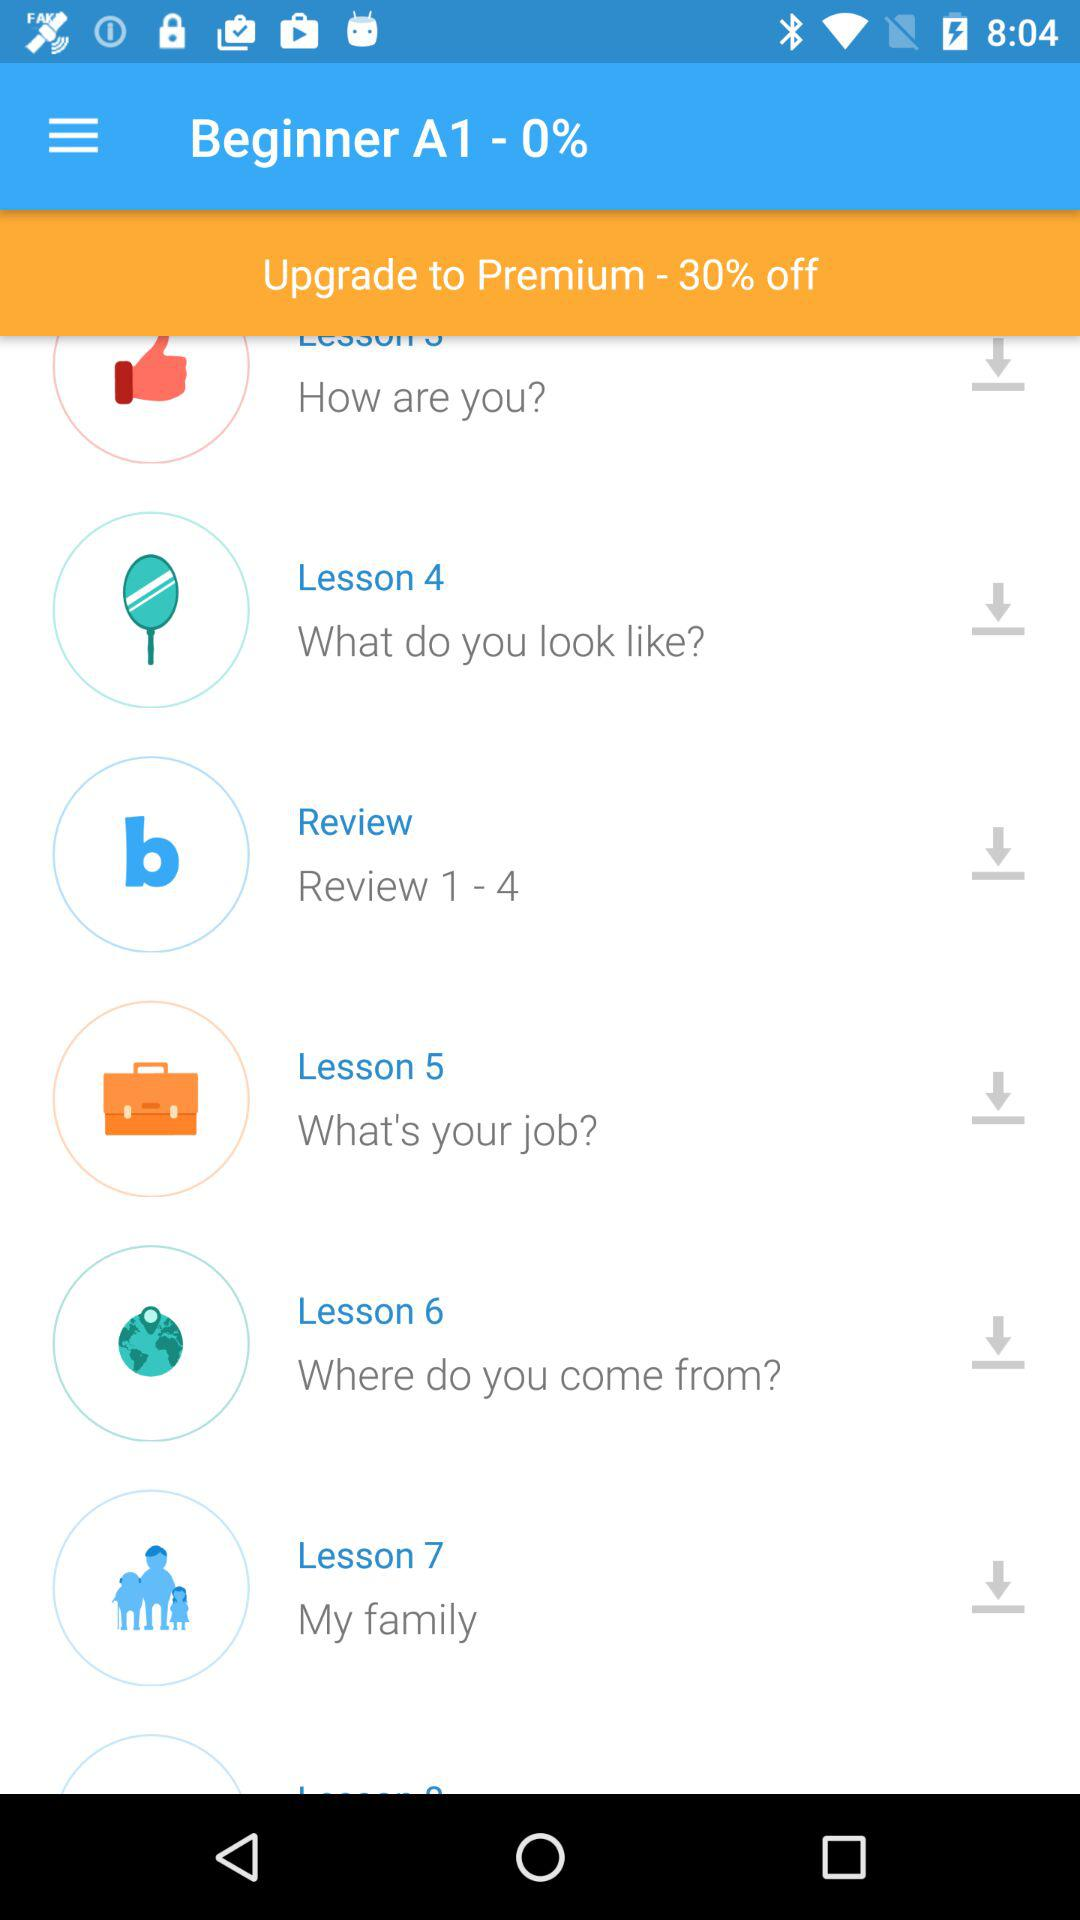What is the topic of Lesson 7? The topic is "My family". 